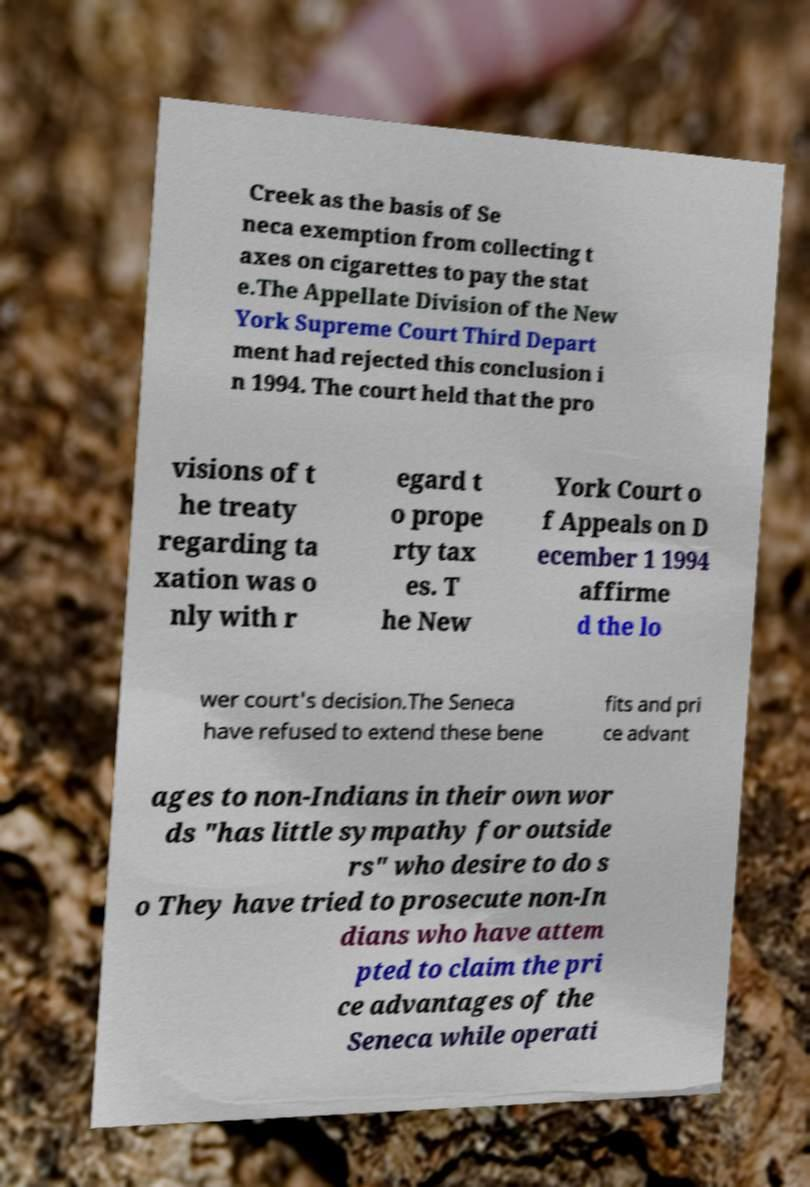Could you assist in decoding the text presented in this image and type it out clearly? Creek as the basis of Se neca exemption from collecting t axes on cigarettes to pay the stat e.The Appellate Division of the New York Supreme Court Third Depart ment had rejected this conclusion i n 1994. The court held that the pro visions of t he treaty regarding ta xation was o nly with r egard t o prope rty tax es. T he New York Court o f Appeals on D ecember 1 1994 affirme d the lo wer court's decision.The Seneca have refused to extend these bene fits and pri ce advant ages to non-Indians in their own wor ds "has little sympathy for outside rs" who desire to do s o They have tried to prosecute non-In dians who have attem pted to claim the pri ce advantages of the Seneca while operati 